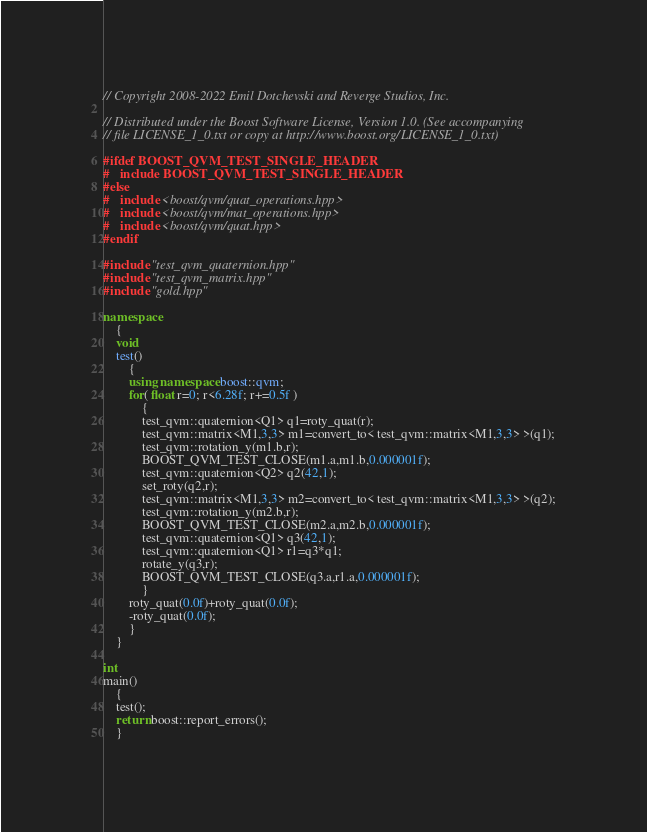<code> <loc_0><loc_0><loc_500><loc_500><_C++_>// Copyright 2008-2022 Emil Dotchevski and Reverge Studios, Inc.

// Distributed under the Boost Software License, Version 1.0. (See accompanying
// file LICENSE_1_0.txt or copy at http://www.boost.org/LICENSE_1_0.txt)

#ifdef BOOST_QVM_TEST_SINGLE_HEADER
#   include BOOST_QVM_TEST_SINGLE_HEADER
#else
#   include <boost/qvm/quat_operations.hpp>
#   include <boost/qvm/mat_operations.hpp>
#   include <boost/qvm/quat.hpp>
#endif

#include "test_qvm_quaternion.hpp"
#include "test_qvm_matrix.hpp"
#include "gold.hpp"

namespace
    {
    void
    test()
        {
        using namespace boost::qvm;
        for( float r=0; r<6.28f; r+=0.5f )
            {
            test_qvm::quaternion<Q1> q1=roty_quat(r);
            test_qvm::matrix<M1,3,3> m1=convert_to< test_qvm::matrix<M1,3,3> >(q1);
            test_qvm::rotation_y(m1.b,r);
            BOOST_QVM_TEST_CLOSE(m1.a,m1.b,0.000001f);
            test_qvm::quaternion<Q2> q2(42,1);
            set_roty(q2,r);
            test_qvm::matrix<M1,3,3> m2=convert_to< test_qvm::matrix<M1,3,3> >(q2);
            test_qvm::rotation_y(m2.b,r);
            BOOST_QVM_TEST_CLOSE(m2.a,m2.b,0.000001f);
            test_qvm::quaternion<Q1> q3(42,1);
            test_qvm::quaternion<Q1> r1=q3*q1;
            rotate_y(q3,r);
            BOOST_QVM_TEST_CLOSE(q3.a,r1.a,0.000001f);
            }
        roty_quat(0.0f)+roty_quat(0.0f);
        -roty_quat(0.0f);
        }
    }

int
main()
    {
    test();
    return boost::report_errors();
    }
</code> 